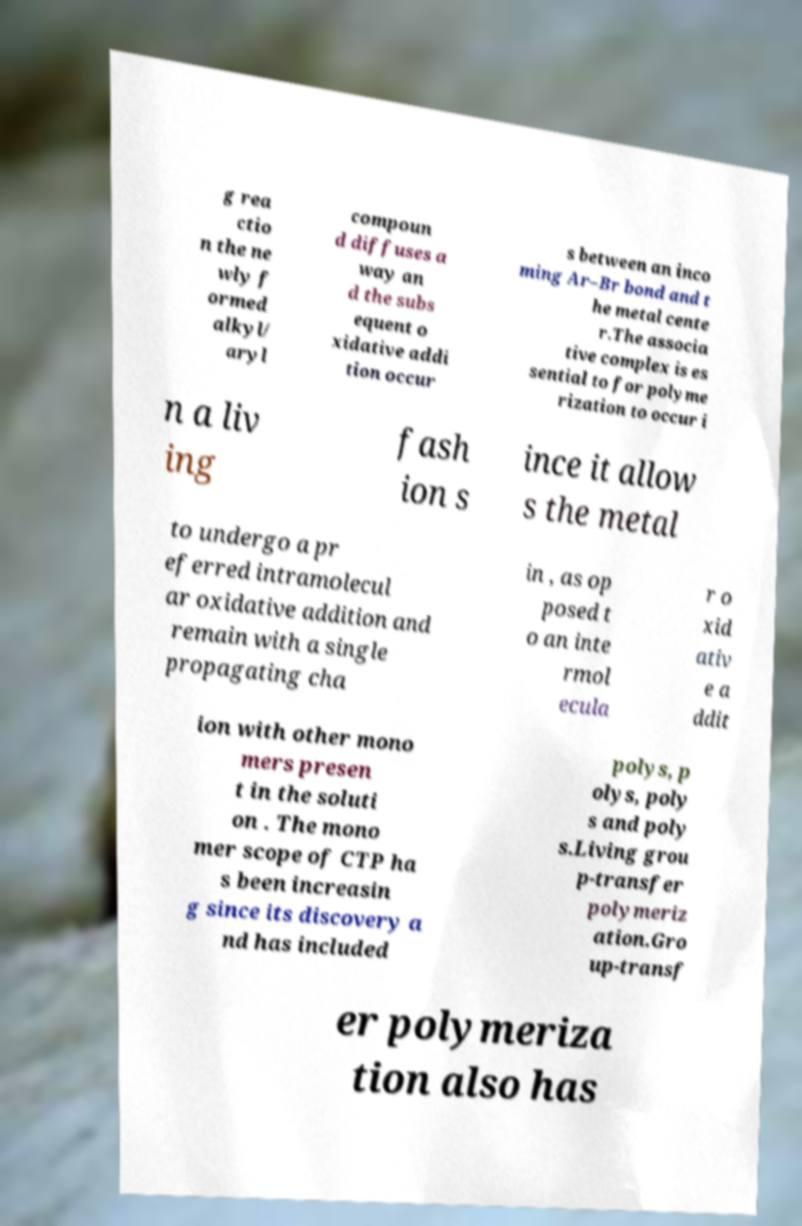Please identify and transcribe the text found in this image. g rea ctio n the ne wly f ormed alkyl/ aryl compoun d diffuses a way an d the subs equent o xidative addi tion occur s between an inco ming Ar–Br bond and t he metal cente r.The associa tive complex is es sential to for polyme rization to occur i n a liv ing fash ion s ince it allow s the metal to undergo a pr eferred intramolecul ar oxidative addition and remain with a single propagating cha in , as op posed t o an inte rmol ecula r o xid ativ e a ddit ion with other mono mers presen t in the soluti on . The mono mer scope of CTP ha s been increasin g since its discovery a nd has included polys, p olys, poly s and poly s.Living grou p-transfer polymeriz ation.Gro up-transf er polymeriza tion also has 